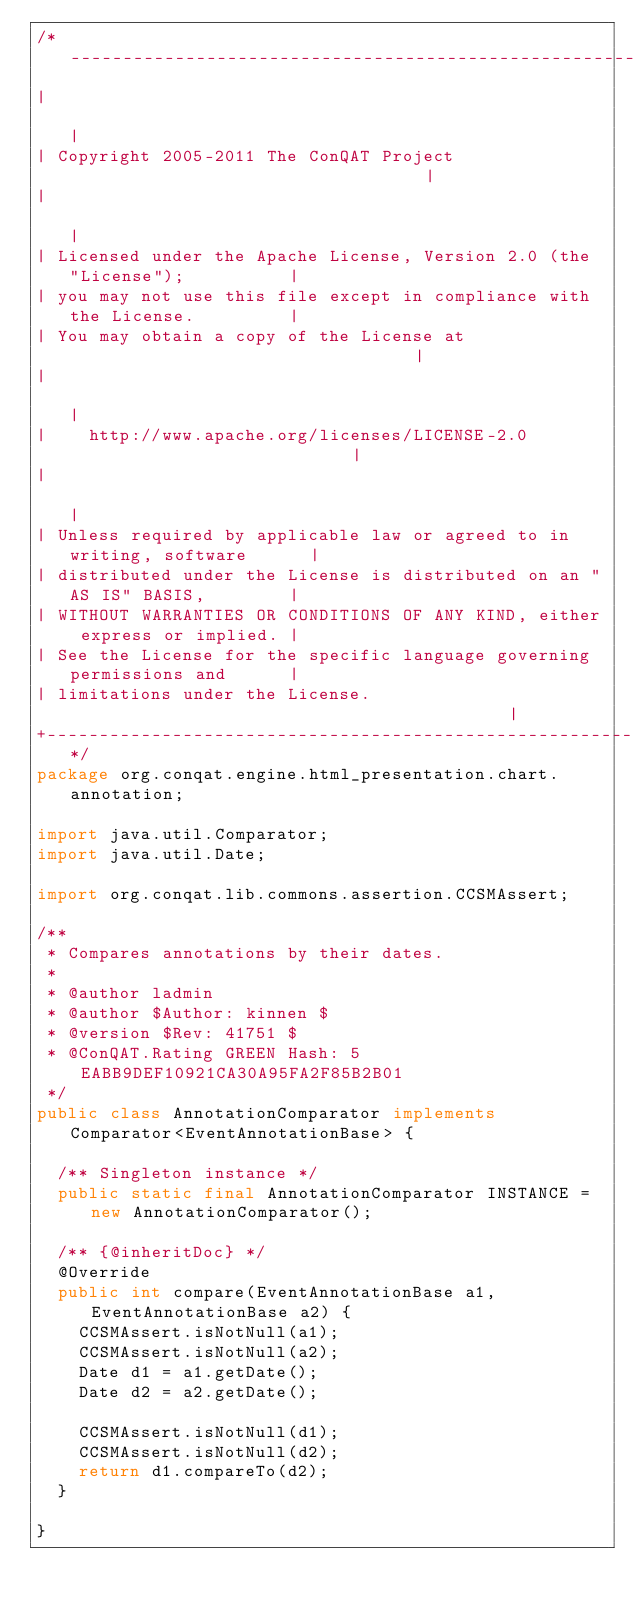Convert code to text. <code><loc_0><loc_0><loc_500><loc_500><_Java_>/*-------------------------------------------------------------------------+
|                                                                          |
| Copyright 2005-2011 The ConQAT Project                                   |
|                                                                          |
| Licensed under the Apache License, Version 2.0 (the "License");          |
| you may not use this file except in compliance with the License.         |
| You may obtain a copy of the License at                                  |
|                                                                          |
|    http://www.apache.org/licenses/LICENSE-2.0                            |
|                                                                          |
| Unless required by applicable law or agreed to in writing, software      |
| distributed under the License is distributed on an "AS IS" BASIS,        |
| WITHOUT WARRANTIES OR CONDITIONS OF ANY KIND, either express or implied. |
| See the License for the specific language governing permissions and      |
| limitations under the License.                                           |
+-------------------------------------------------------------------------*/
package org.conqat.engine.html_presentation.chart.annotation;

import java.util.Comparator;
import java.util.Date;

import org.conqat.lib.commons.assertion.CCSMAssert;

/**
 * Compares annotations by their dates.
 * 
 * @author ladmin
 * @author $Author: kinnen $
 * @version $Rev: 41751 $
 * @ConQAT.Rating GREEN Hash: 5EABB9DEF10921CA30A95FA2F85B2B01
 */
public class AnnotationComparator implements Comparator<EventAnnotationBase> {

	/** Singleton instance */
	public static final AnnotationComparator INSTANCE = new AnnotationComparator();

	/** {@inheritDoc} */
	@Override
	public int compare(EventAnnotationBase a1, EventAnnotationBase a2) {
		CCSMAssert.isNotNull(a1);
		CCSMAssert.isNotNull(a2);
		Date d1 = a1.getDate();
		Date d2 = a2.getDate();

		CCSMAssert.isNotNull(d1);
		CCSMAssert.isNotNull(d2);
		return d1.compareTo(d2);
	}

}</code> 